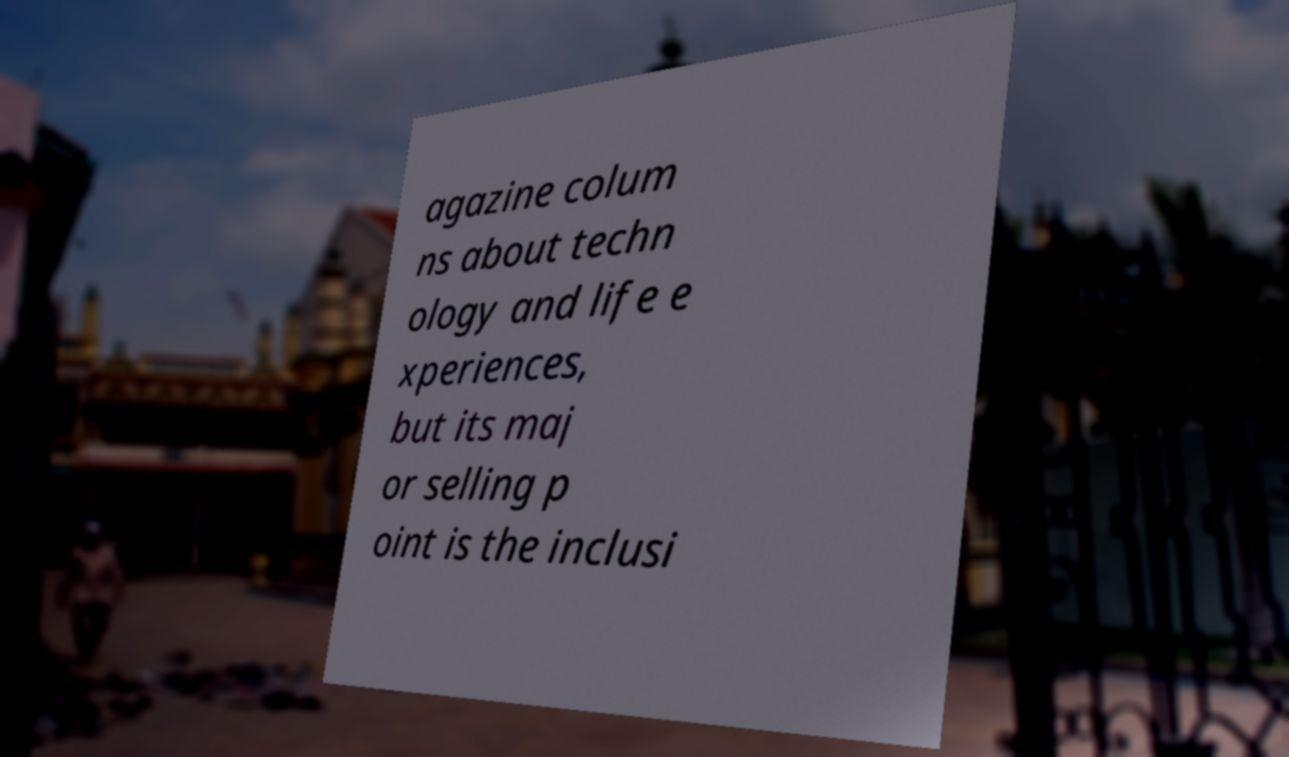Could you extract and type out the text from this image? agazine colum ns about techn ology and life e xperiences, but its maj or selling p oint is the inclusi 